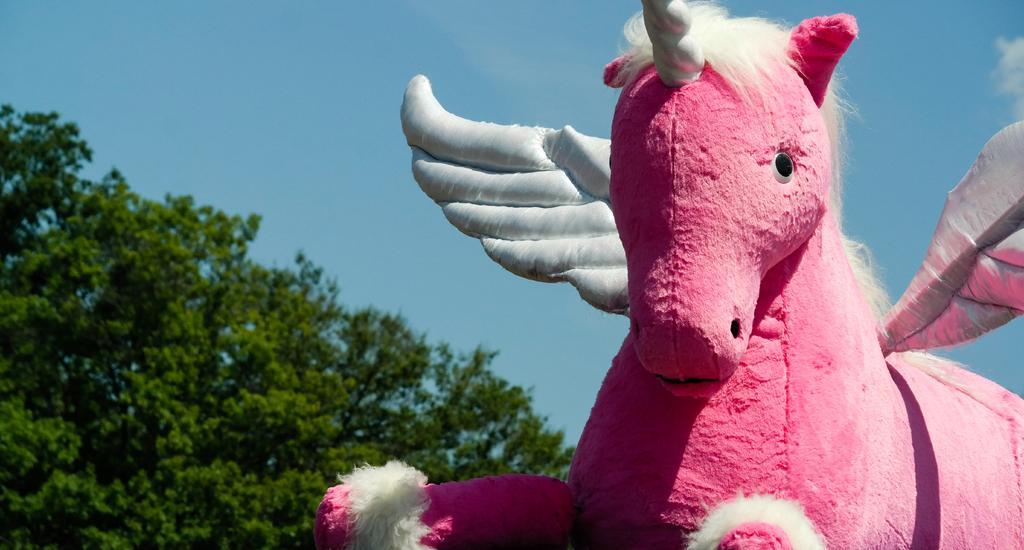In one or two sentences, can you explain what this image depicts? In this image we can see a pink color unicorn statue. Behind trees are there. The sky is in blue color. 